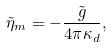Convert formula to latex. <formula><loc_0><loc_0><loc_500><loc_500>\tilde { \eta } _ { m } = - \frac { \tilde { g } } { 4 \pi \kappa _ { d } } ,</formula> 